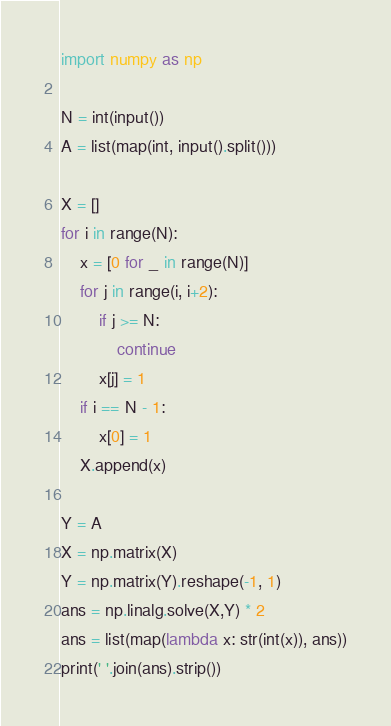Convert code to text. <code><loc_0><loc_0><loc_500><loc_500><_Python_>import numpy as np

N = int(input())
A = list(map(int, input().split()))

X = []
for i in range(N):
    x = [0 for _ in range(N)]
    for j in range(i, i+2):
        if j >= N:
            continue
        x[j] = 1
    if i == N - 1:
        x[0] = 1
    X.append(x)

Y = A
X = np.matrix(X)
Y = np.matrix(Y).reshape(-1, 1)
ans = np.linalg.solve(X,Y) * 2
ans = list(map(lambda x: str(int(x)), ans))
print(' '.join(ans).strip())
</code> 